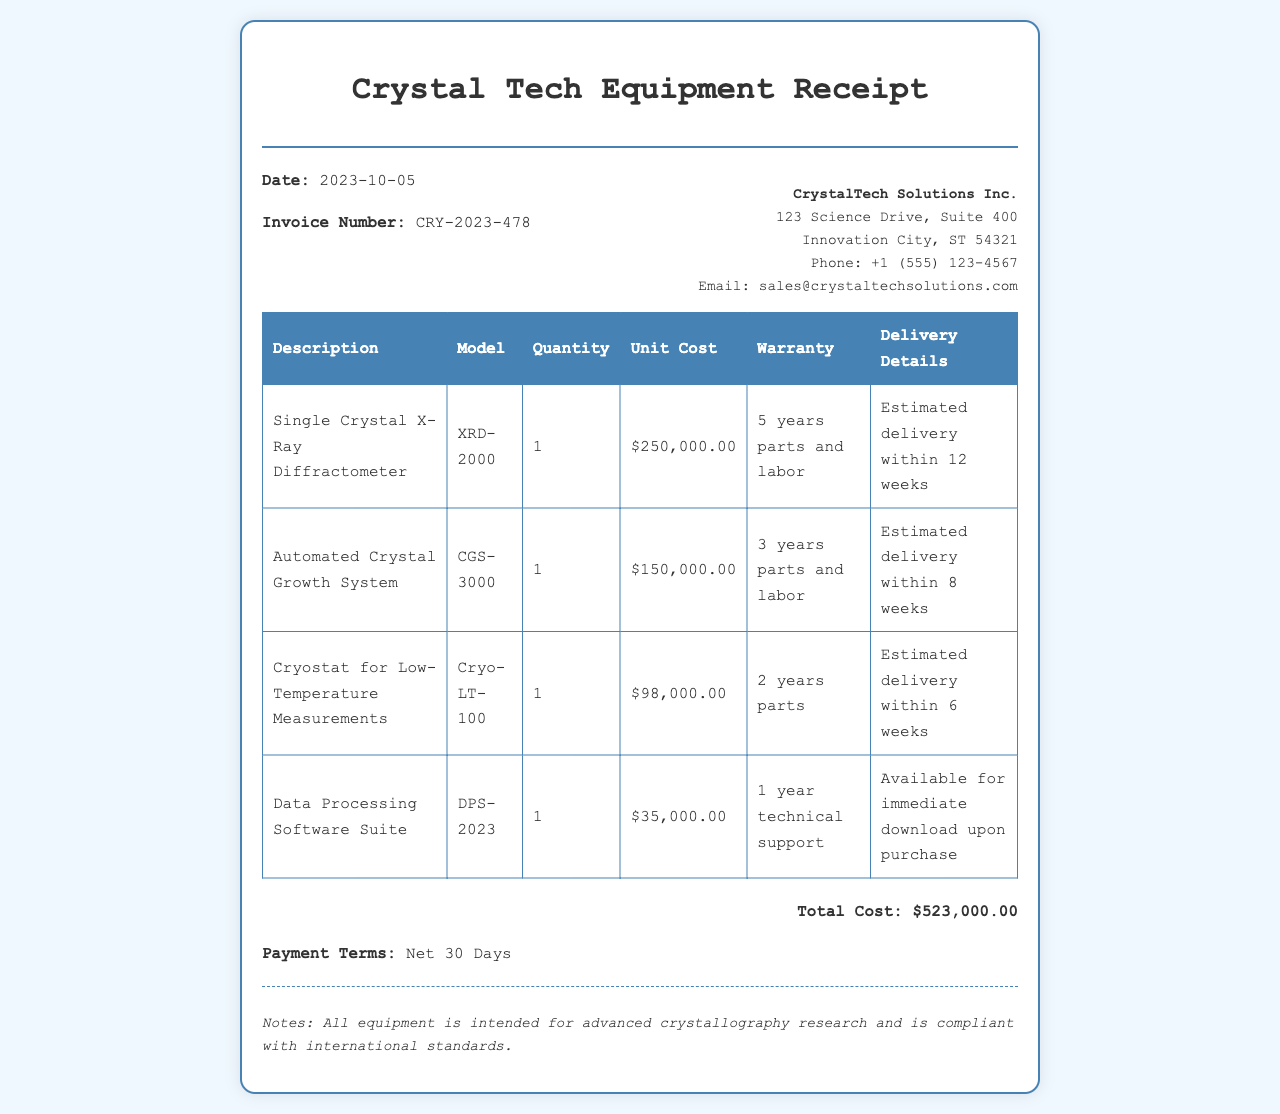What is the total cost of the equipment? The total cost is explicitly stated at the end of the receipt as a summation of all item prices.
Answer: $523,000.00 Who is the vendor for the equipment? The vendor's name is provided at the top of the receipt.
Answer: CrystalTech Solutions Inc What is the model of the Cryostat? The model information is included in the itemized table for the Cryostat.
Answer: Cryo-LT-100 What warranty duration does the Single Crystal X-Ray Diffractometer have? Warranty details are specified in the table under the warranty column for the respective item.
Answer: 5 years parts and labor When is the estimated delivery for the Automated Crystal Growth System? The delivery information is provided in the table for each piece of equipment.
Answer: Estimated delivery within 8 weeks What is the invoice number? The invoice number is listed in the invoice details section.
Answer: CRY-2023-478 How many units of Data Processing Software Suite were acquired? The quantity of each item is detailed in the itemized table.
Answer: 1 What is the payment term stated in the receipt? The payment terms are mentioned at the bottom of the receipt.
Answer: Net 30 Days What is the model of the Data Processing Software Suite? The model for the software suite is identified in the description column of the table.
Answer: DPS-2023 